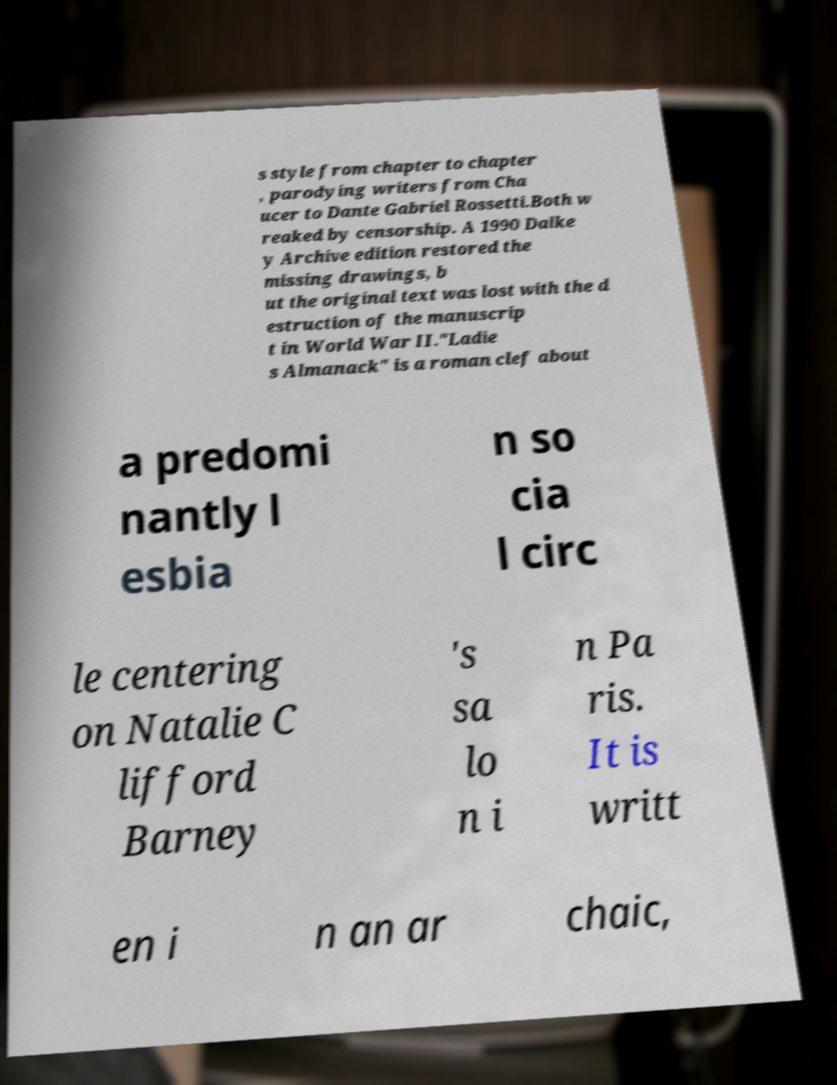Please identify and transcribe the text found in this image. s style from chapter to chapter , parodying writers from Cha ucer to Dante Gabriel Rossetti.Both w reaked by censorship. A 1990 Dalke y Archive edition restored the missing drawings, b ut the original text was lost with the d estruction of the manuscrip t in World War II."Ladie s Almanack" is a roman clef about a predomi nantly l esbia n so cia l circ le centering on Natalie C lifford Barney 's sa lo n i n Pa ris. It is writt en i n an ar chaic, 